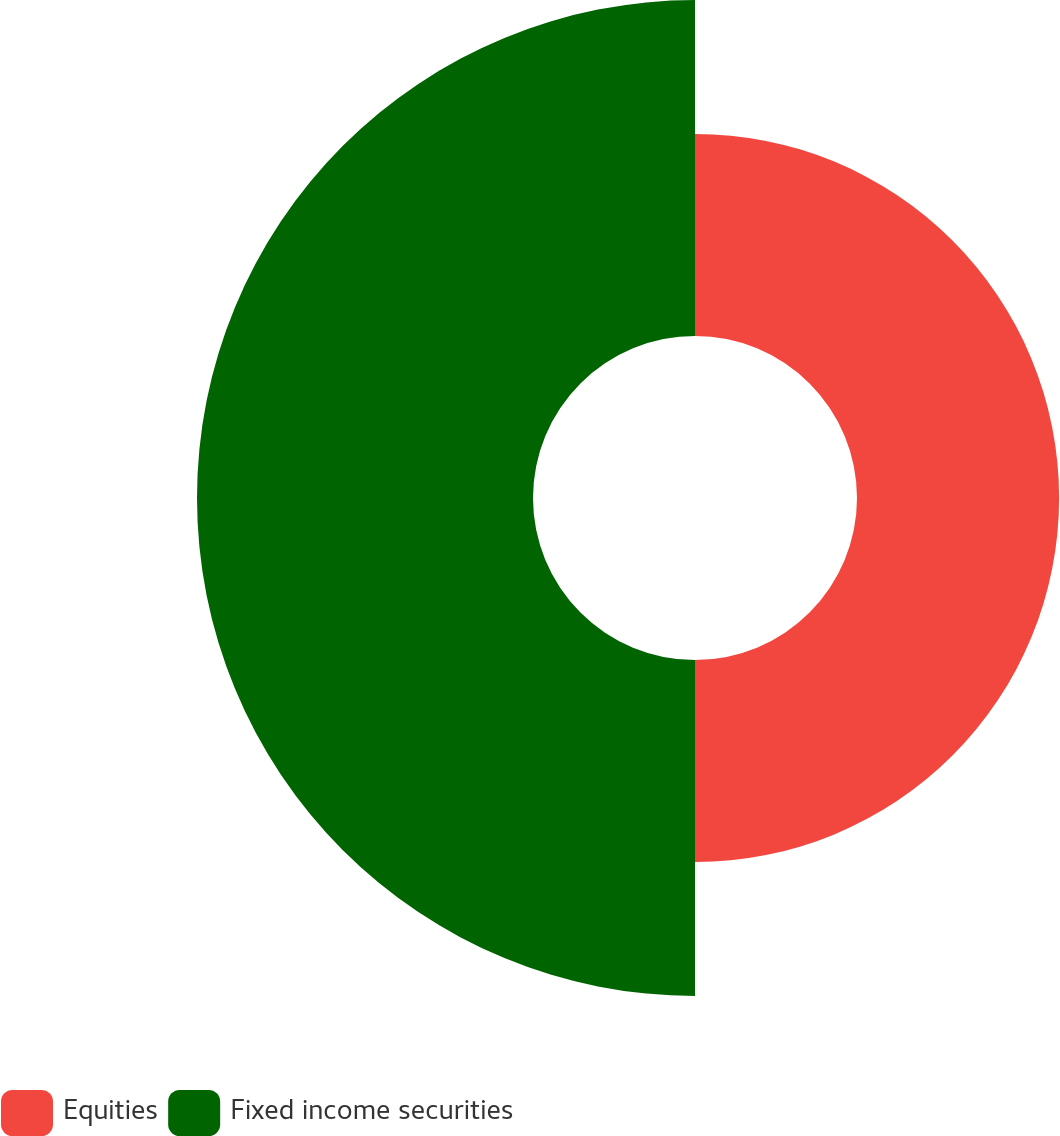Convert chart. <chart><loc_0><loc_0><loc_500><loc_500><pie_chart><fcel>Equities<fcel>Fixed income securities<nl><fcel>37.56%<fcel>62.44%<nl></chart> 